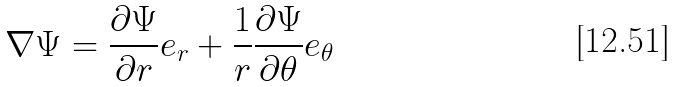Convert formula to latex. <formula><loc_0><loc_0><loc_500><loc_500>\nabla \Psi = { \frac { \partial \Psi } { \partial r } } { e } _ { r } + { \frac { 1 } { r } } { \frac { \partial \Psi } { \partial \theta } } { e } _ { \theta }</formula> 